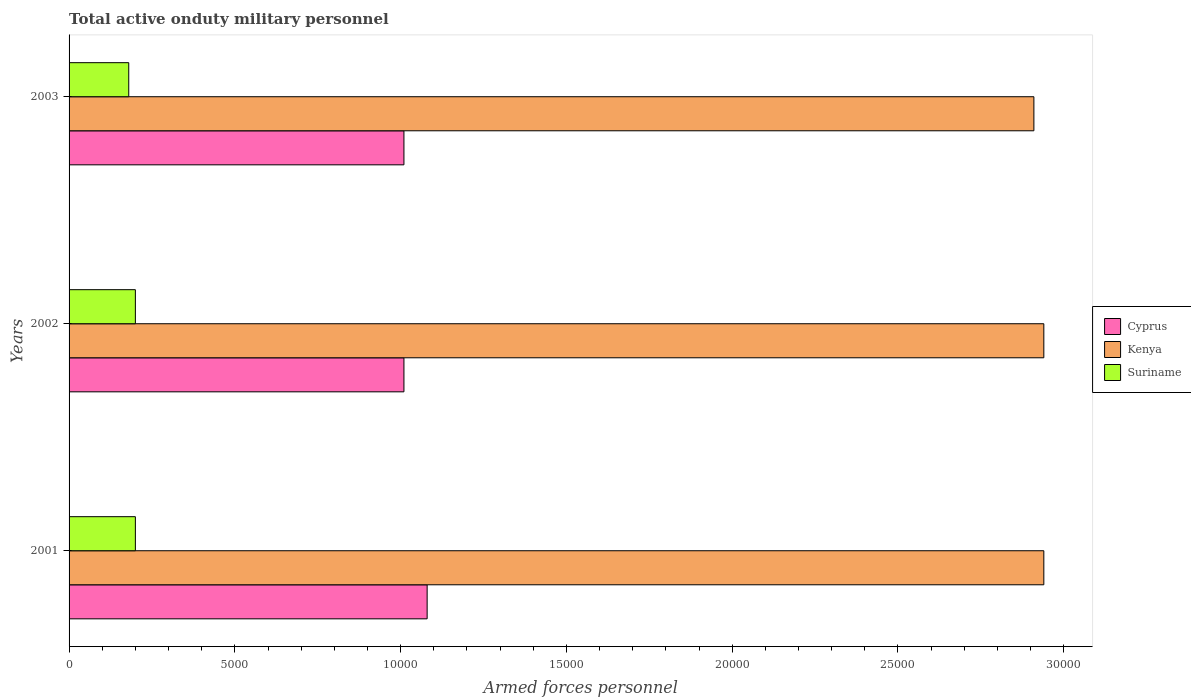Are the number of bars on each tick of the Y-axis equal?
Provide a short and direct response. Yes. How many bars are there on the 3rd tick from the bottom?
Give a very brief answer. 3. What is the label of the 3rd group of bars from the top?
Keep it short and to the point. 2001. What is the number of armed forces personnel in Kenya in 2003?
Your response must be concise. 2.91e+04. Across all years, what is the maximum number of armed forces personnel in Suriname?
Your answer should be very brief. 2000. Across all years, what is the minimum number of armed forces personnel in Kenya?
Provide a short and direct response. 2.91e+04. In which year was the number of armed forces personnel in Cyprus minimum?
Provide a succinct answer. 2002. What is the total number of armed forces personnel in Cyprus in the graph?
Make the answer very short. 3.10e+04. What is the difference between the number of armed forces personnel in Kenya in 2001 and that in 2003?
Your answer should be very brief. 300. What is the difference between the number of armed forces personnel in Cyprus in 2001 and the number of armed forces personnel in Suriname in 2002?
Your answer should be compact. 8800. What is the average number of armed forces personnel in Kenya per year?
Your answer should be compact. 2.93e+04. In the year 2003, what is the difference between the number of armed forces personnel in Suriname and number of armed forces personnel in Kenya?
Make the answer very short. -2.73e+04. In how many years, is the number of armed forces personnel in Kenya greater than 11000 ?
Give a very brief answer. 3. What is the ratio of the number of armed forces personnel in Suriname in 2001 to that in 2003?
Make the answer very short. 1.11. Is the number of armed forces personnel in Cyprus in 2001 less than that in 2003?
Offer a terse response. No. Is the difference between the number of armed forces personnel in Suriname in 2002 and 2003 greater than the difference between the number of armed forces personnel in Kenya in 2002 and 2003?
Keep it short and to the point. No. What is the difference between the highest and the second highest number of armed forces personnel in Suriname?
Give a very brief answer. 0. What is the difference between the highest and the lowest number of armed forces personnel in Kenya?
Give a very brief answer. 300. Is the sum of the number of armed forces personnel in Cyprus in 2001 and 2003 greater than the maximum number of armed forces personnel in Kenya across all years?
Provide a short and direct response. No. What does the 2nd bar from the top in 2002 represents?
Give a very brief answer. Kenya. What does the 1st bar from the bottom in 2001 represents?
Give a very brief answer. Cyprus. Is it the case that in every year, the sum of the number of armed forces personnel in Cyprus and number of armed forces personnel in Kenya is greater than the number of armed forces personnel in Suriname?
Provide a succinct answer. Yes. How many bars are there?
Offer a terse response. 9. Are all the bars in the graph horizontal?
Offer a terse response. Yes. How many years are there in the graph?
Offer a very short reply. 3. What is the difference between two consecutive major ticks on the X-axis?
Your response must be concise. 5000. Does the graph contain grids?
Offer a terse response. No. What is the title of the graph?
Your answer should be very brief. Total active onduty military personnel. Does "Mozambique" appear as one of the legend labels in the graph?
Ensure brevity in your answer.  No. What is the label or title of the X-axis?
Offer a very short reply. Armed forces personnel. What is the Armed forces personnel in Cyprus in 2001?
Your answer should be very brief. 1.08e+04. What is the Armed forces personnel in Kenya in 2001?
Offer a very short reply. 2.94e+04. What is the Armed forces personnel of Cyprus in 2002?
Offer a terse response. 1.01e+04. What is the Armed forces personnel of Kenya in 2002?
Make the answer very short. 2.94e+04. What is the Armed forces personnel of Cyprus in 2003?
Offer a terse response. 1.01e+04. What is the Armed forces personnel of Kenya in 2003?
Keep it short and to the point. 2.91e+04. What is the Armed forces personnel in Suriname in 2003?
Keep it short and to the point. 1800. Across all years, what is the maximum Armed forces personnel of Cyprus?
Make the answer very short. 1.08e+04. Across all years, what is the maximum Armed forces personnel in Kenya?
Keep it short and to the point. 2.94e+04. Across all years, what is the minimum Armed forces personnel of Cyprus?
Keep it short and to the point. 1.01e+04. Across all years, what is the minimum Armed forces personnel of Kenya?
Offer a terse response. 2.91e+04. Across all years, what is the minimum Armed forces personnel in Suriname?
Provide a succinct answer. 1800. What is the total Armed forces personnel of Cyprus in the graph?
Your answer should be very brief. 3.10e+04. What is the total Armed forces personnel of Kenya in the graph?
Offer a very short reply. 8.79e+04. What is the total Armed forces personnel in Suriname in the graph?
Offer a terse response. 5800. What is the difference between the Armed forces personnel of Cyprus in 2001 and that in 2002?
Your answer should be very brief. 700. What is the difference between the Armed forces personnel in Suriname in 2001 and that in 2002?
Your answer should be compact. 0. What is the difference between the Armed forces personnel of Cyprus in 2001 and that in 2003?
Ensure brevity in your answer.  700. What is the difference between the Armed forces personnel of Kenya in 2001 and that in 2003?
Provide a short and direct response. 300. What is the difference between the Armed forces personnel in Kenya in 2002 and that in 2003?
Your answer should be compact. 300. What is the difference between the Armed forces personnel in Suriname in 2002 and that in 2003?
Make the answer very short. 200. What is the difference between the Armed forces personnel of Cyprus in 2001 and the Armed forces personnel of Kenya in 2002?
Your response must be concise. -1.86e+04. What is the difference between the Armed forces personnel of Cyprus in 2001 and the Armed forces personnel of Suriname in 2002?
Give a very brief answer. 8800. What is the difference between the Armed forces personnel in Kenya in 2001 and the Armed forces personnel in Suriname in 2002?
Ensure brevity in your answer.  2.74e+04. What is the difference between the Armed forces personnel in Cyprus in 2001 and the Armed forces personnel in Kenya in 2003?
Keep it short and to the point. -1.83e+04. What is the difference between the Armed forces personnel in Cyprus in 2001 and the Armed forces personnel in Suriname in 2003?
Give a very brief answer. 9000. What is the difference between the Armed forces personnel in Kenya in 2001 and the Armed forces personnel in Suriname in 2003?
Your response must be concise. 2.76e+04. What is the difference between the Armed forces personnel in Cyprus in 2002 and the Armed forces personnel in Kenya in 2003?
Your response must be concise. -1.90e+04. What is the difference between the Armed forces personnel of Cyprus in 2002 and the Armed forces personnel of Suriname in 2003?
Provide a succinct answer. 8300. What is the difference between the Armed forces personnel of Kenya in 2002 and the Armed forces personnel of Suriname in 2003?
Your response must be concise. 2.76e+04. What is the average Armed forces personnel in Cyprus per year?
Provide a short and direct response. 1.03e+04. What is the average Armed forces personnel of Kenya per year?
Your answer should be very brief. 2.93e+04. What is the average Armed forces personnel in Suriname per year?
Give a very brief answer. 1933.33. In the year 2001, what is the difference between the Armed forces personnel in Cyprus and Armed forces personnel in Kenya?
Offer a terse response. -1.86e+04. In the year 2001, what is the difference between the Armed forces personnel of Cyprus and Armed forces personnel of Suriname?
Provide a short and direct response. 8800. In the year 2001, what is the difference between the Armed forces personnel in Kenya and Armed forces personnel in Suriname?
Make the answer very short. 2.74e+04. In the year 2002, what is the difference between the Armed forces personnel of Cyprus and Armed forces personnel of Kenya?
Offer a very short reply. -1.93e+04. In the year 2002, what is the difference between the Armed forces personnel in Cyprus and Armed forces personnel in Suriname?
Offer a terse response. 8100. In the year 2002, what is the difference between the Armed forces personnel of Kenya and Armed forces personnel of Suriname?
Give a very brief answer. 2.74e+04. In the year 2003, what is the difference between the Armed forces personnel of Cyprus and Armed forces personnel of Kenya?
Keep it short and to the point. -1.90e+04. In the year 2003, what is the difference between the Armed forces personnel in Cyprus and Armed forces personnel in Suriname?
Give a very brief answer. 8300. In the year 2003, what is the difference between the Armed forces personnel of Kenya and Armed forces personnel of Suriname?
Offer a very short reply. 2.73e+04. What is the ratio of the Armed forces personnel of Cyprus in 2001 to that in 2002?
Your answer should be very brief. 1.07. What is the ratio of the Armed forces personnel of Kenya in 2001 to that in 2002?
Give a very brief answer. 1. What is the ratio of the Armed forces personnel of Cyprus in 2001 to that in 2003?
Make the answer very short. 1.07. What is the ratio of the Armed forces personnel in Kenya in 2001 to that in 2003?
Offer a terse response. 1.01. What is the ratio of the Armed forces personnel in Kenya in 2002 to that in 2003?
Your answer should be compact. 1.01. What is the difference between the highest and the second highest Armed forces personnel in Cyprus?
Your answer should be compact. 700. What is the difference between the highest and the lowest Armed forces personnel in Cyprus?
Offer a very short reply. 700. What is the difference between the highest and the lowest Armed forces personnel in Kenya?
Your response must be concise. 300. What is the difference between the highest and the lowest Armed forces personnel of Suriname?
Offer a terse response. 200. 